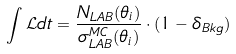Convert formula to latex. <formula><loc_0><loc_0><loc_500><loc_500>\int { \mathcal { L } } d t = \frac { N _ { L A B } ( \theta _ { i } ) } { \sigma _ { L A B } ^ { M C } ( \theta _ { i } ) } \cdot ( 1 - \delta _ { B k g } )</formula> 